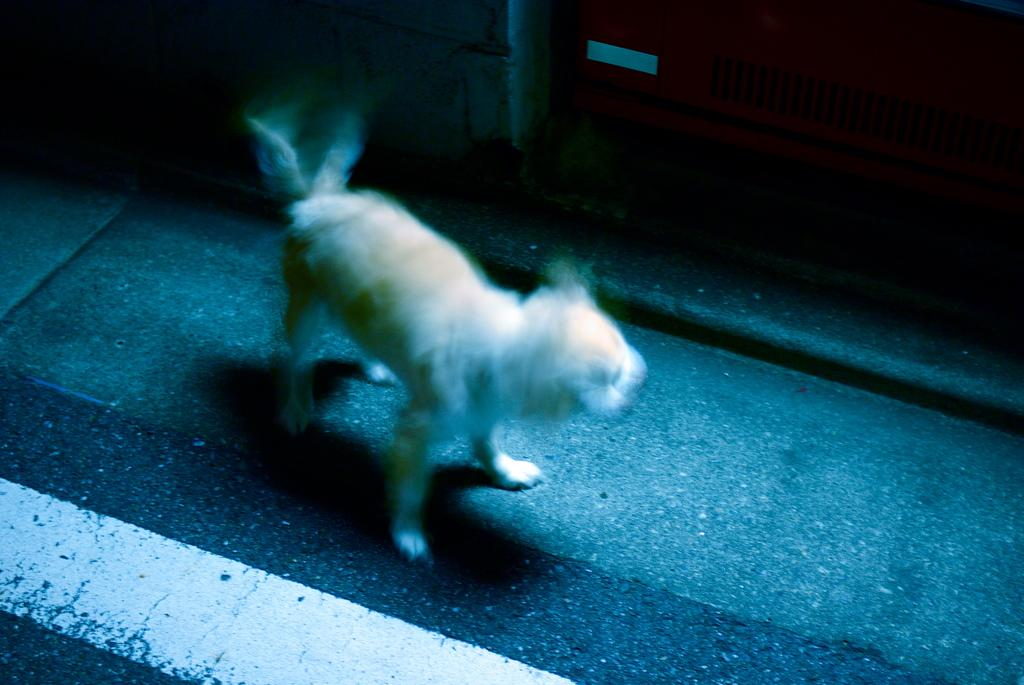What type of animal is present in the image? There is a white color dog in the image. Where is the dog located in the image? The dog is standing on the road. What type of verse is the dog reciting in the image? There is no indication in the image that the dog is reciting any verse. 